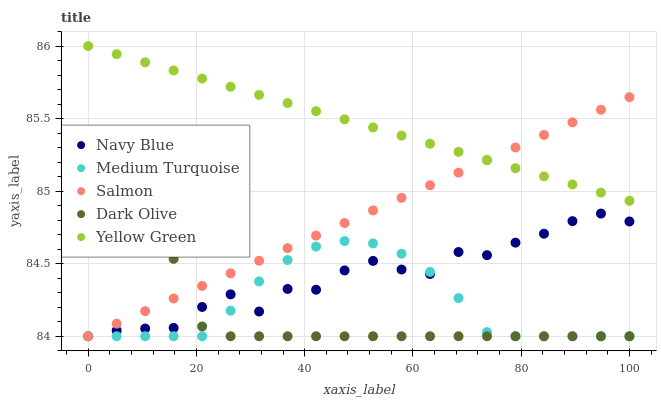Does Dark Olive have the minimum area under the curve?
Answer yes or no. Yes. Does Yellow Green have the maximum area under the curve?
Answer yes or no. Yes. Does Salmon have the minimum area under the curve?
Answer yes or no. No. Does Salmon have the maximum area under the curve?
Answer yes or no. No. Is Salmon the smoothest?
Answer yes or no. Yes. Is Navy Blue the roughest?
Answer yes or no. Yes. Is Dark Olive the smoothest?
Answer yes or no. No. Is Dark Olive the roughest?
Answer yes or no. No. Does Navy Blue have the lowest value?
Answer yes or no. Yes. Does Yellow Green have the lowest value?
Answer yes or no. No. Does Yellow Green have the highest value?
Answer yes or no. Yes. Does Dark Olive have the highest value?
Answer yes or no. No. Is Dark Olive less than Yellow Green?
Answer yes or no. Yes. Is Yellow Green greater than Navy Blue?
Answer yes or no. Yes. Does Salmon intersect Yellow Green?
Answer yes or no. Yes. Is Salmon less than Yellow Green?
Answer yes or no. No. Is Salmon greater than Yellow Green?
Answer yes or no. No. Does Dark Olive intersect Yellow Green?
Answer yes or no. No. 